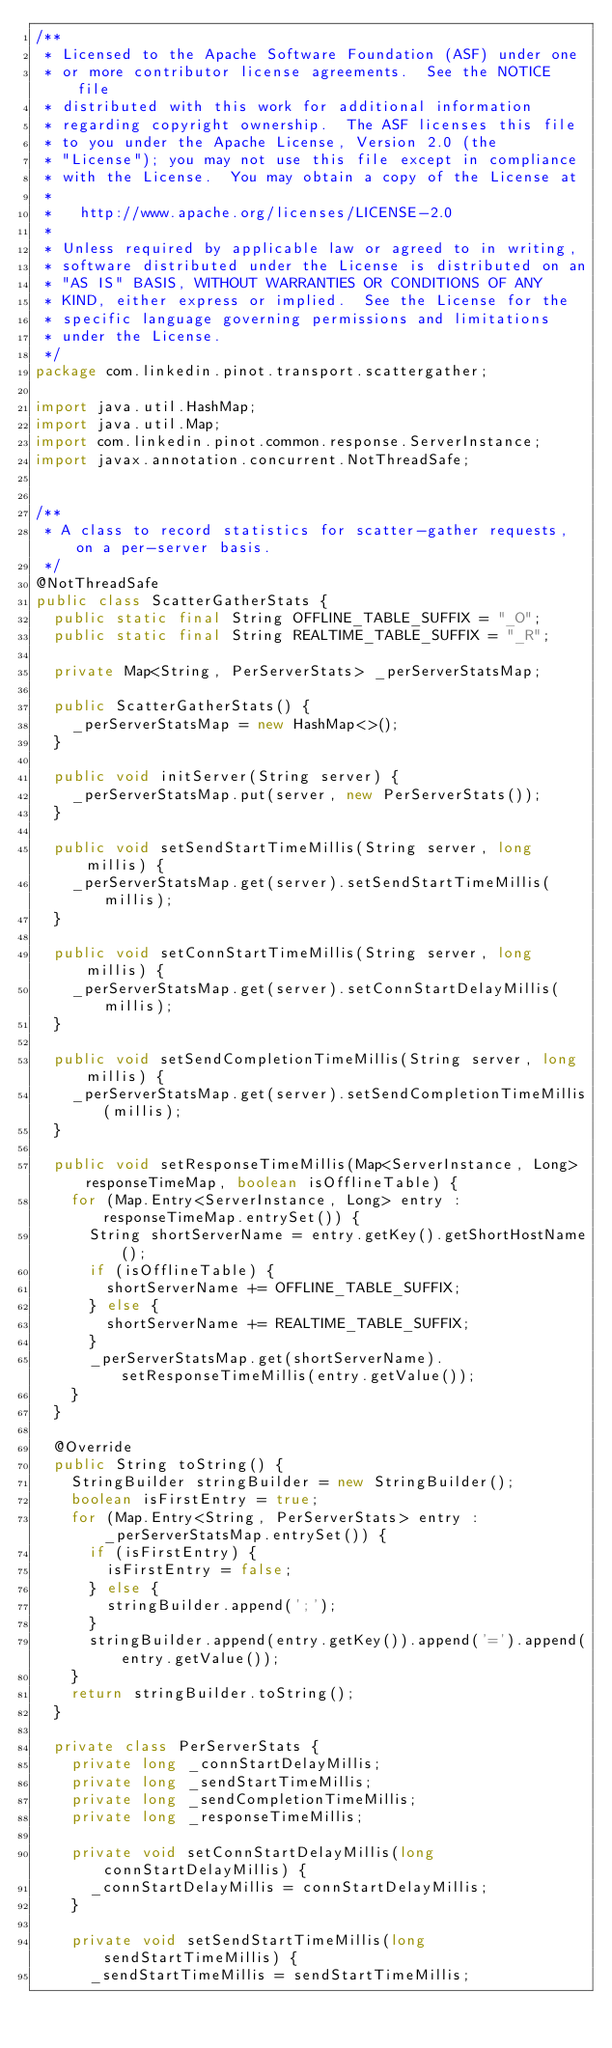Convert code to text. <code><loc_0><loc_0><loc_500><loc_500><_Java_>/**
 * Licensed to the Apache Software Foundation (ASF) under one
 * or more contributor license agreements.  See the NOTICE file
 * distributed with this work for additional information
 * regarding copyright ownership.  The ASF licenses this file
 * to you under the Apache License, Version 2.0 (the
 * "License"); you may not use this file except in compliance
 * with the License.  You may obtain a copy of the License at
 *
 *   http://www.apache.org/licenses/LICENSE-2.0
 *
 * Unless required by applicable law or agreed to in writing,
 * software distributed under the License is distributed on an
 * "AS IS" BASIS, WITHOUT WARRANTIES OR CONDITIONS OF ANY
 * KIND, either express or implied.  See the License for the
 * specific language governing permissions and limitations
 * under the License.
 */
package com.linkedin.pinot.transport.scattergather;

import java.util.HashMap;
import java.util.Map;
import com.linkedin.pinot.common.response.ServerInstance;
import javax.annotation.concurrent.NotThreadSafe;


/**
 * A class to record statistics for scatter-gather requests, on a per-server basis.
 */
@NotThreadSafe
public class ScatterGatherStats {
  public static final String OFFLINE_TABLE_SUFFIX = "_O";
  public static final String REALTIME_TABLE_SUFFIX = "_R";

  private Map<String, PerServerStats> _perServerStatsMap;

  public ScatterGatherStats() {
    _perServerStatsMap = new HashMap<>();
  }

  public void initServer(String server) {
    _perServerStatsMap.put(server, new PerServerStats());
  }

  public void setSendStartTimeMillis(String server, long millis) {
    _perServerStatsMap.get(server).setSendStartTimeMillis(millis);
  }

  public void setConnStartTimeMillis(String server, long millis) {
    _perServerStatsMap.get(server).setConnStartDelayMillis(millis);
  }

  public void setSendCompletionTimeMillis(String server, long millis) {
    _perServerStatsMap.get(server).setSendCompletionTimeMillis(millis);
  }

  public void setResponseTimeMillis(Map<ServerInstance, Long> responseTimeMap, boolean isOfflineTable) {
    for (Map.Entry<ServerInstance, Long> entry : responseTimeMap.entrySet()) {
      String shortServerName = entry.getKey().getShortHostName();
      if (isOfflineTable) {
        shortServerName += OFFLINE_TABLE_SUFFIX;
      } else {
        shortServerName += REALTIME_TABLE_SUFFIX;
      }
      _perServerStatsMap.get(shortServerName).setResponseTimeMillis(entry.getValue());
    }
  }

  @Override
  public String toString() {
    StringBuilder stringBuilder = new StringBuilder();
    boolean isFirstEntry = true;
    for (Map.Entry<String, PerServerStats> entry : _perServerStatsMap.entrySet()) {
      if (isFirstEntry) {
        isFirstEntry = false;
      } else {
        stringBuilder.append(';');
      }
      stringBuilder.append(entry.getKey()).append('=').append(entry.getValue());
    }
    return stringBuilder.toString();
  }

  private class PerServerStats {
    private long _connStartDelayMillis;
    private long _sendStartTimeMillis;
    private long _sendCompletionTimeMillis;
    private long _responseTimeMillis;

    private void setConnStartDelayMillis(long connStartDelayMillis) {
      _connStartDelayMillis = connStartDelayMillis;
    }

    private void setSendStartTimeMillis(long sendStartTimeMillis) {
      _sendStartTimeMillis = sendStartTimeMillis;</code> 